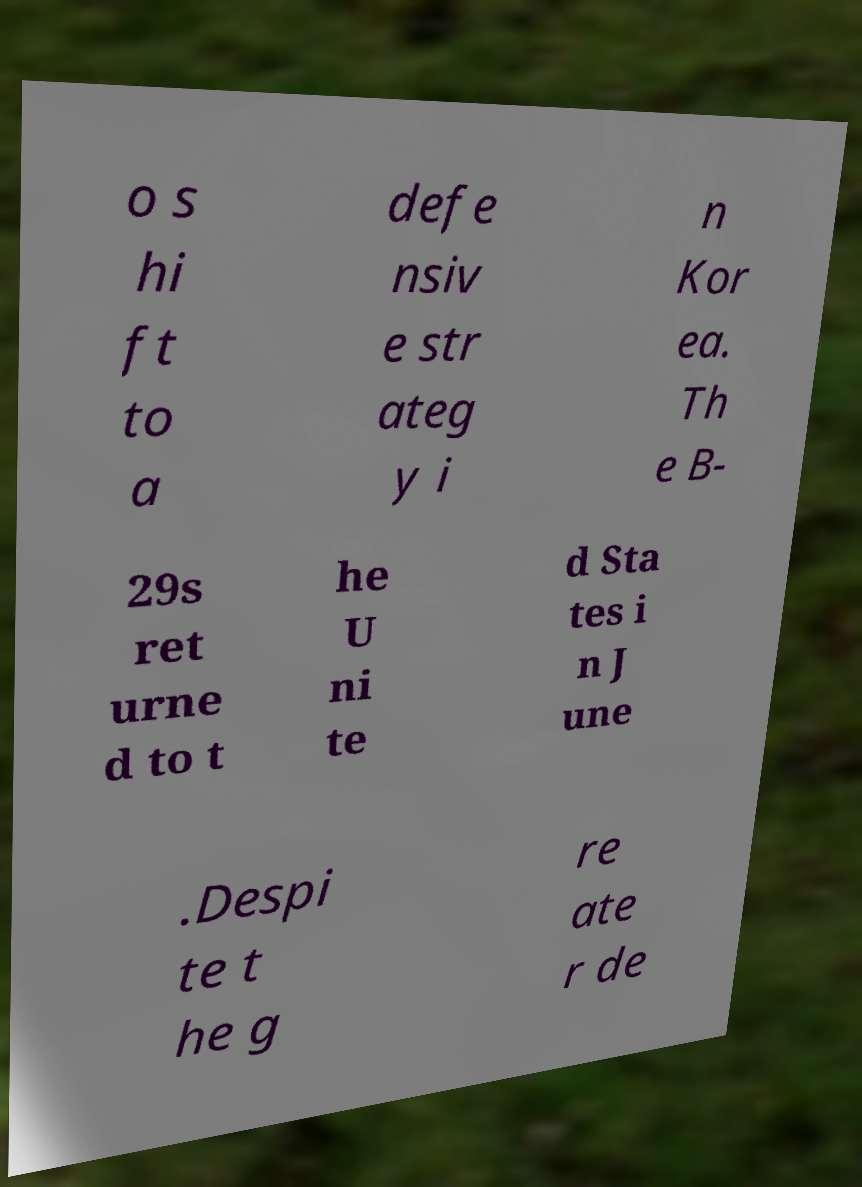Please identify and transcribe the text found in this image. o s hi ft to a defe nsiv e str ateg y i n Kor ea. Th e B- 29s ret urne d to t he U ni te d Sta tes i n J une .Despi te t he g re ate r de 